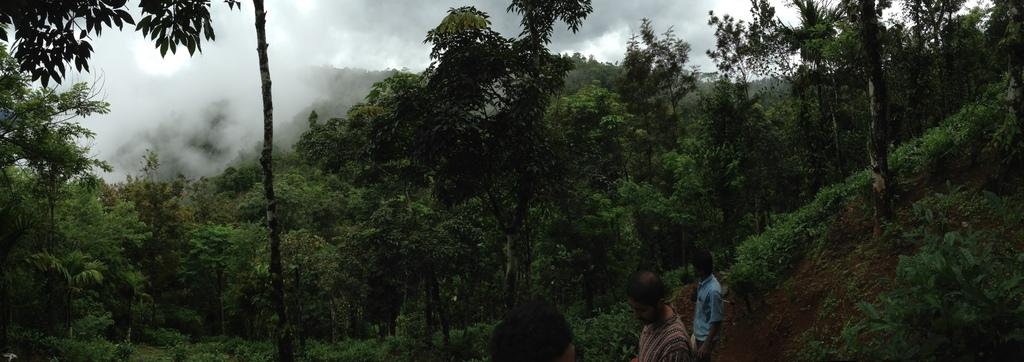What type of natural elements can be seen in the image? There are trees and plants in the image. What geographical feature is visible in the image? There are mountains covered with trees in the image. What is the weather like in the image? The sky is cloudy in the image. What are the people in the image doing? There are people walking at the right side of the image. What arithmetic problem is being solved by the trees in the image? There is no arithmetic problem being solved by the trees in the image; they are simply part of the natural landscape. Is there a party happening in the image? There is no indication of a party in the image; it primarily features natural elements and people walking. 